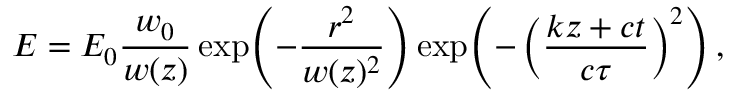Convert formula to latex. <formula><loc_0><loc_0><loc_500><loc_500>E = E _ { 0 } \frac { w _ { 0 } } { w ( z ) } \exp \, \left ( - \frac { r ^ { 2 } } { w ( z ) ^ { 2 } } \right ) \exp \, \left ( - \left ( \frac { k z + c t } { c \tau } \right ) ^ { 2 } \right ) ,</formula> 